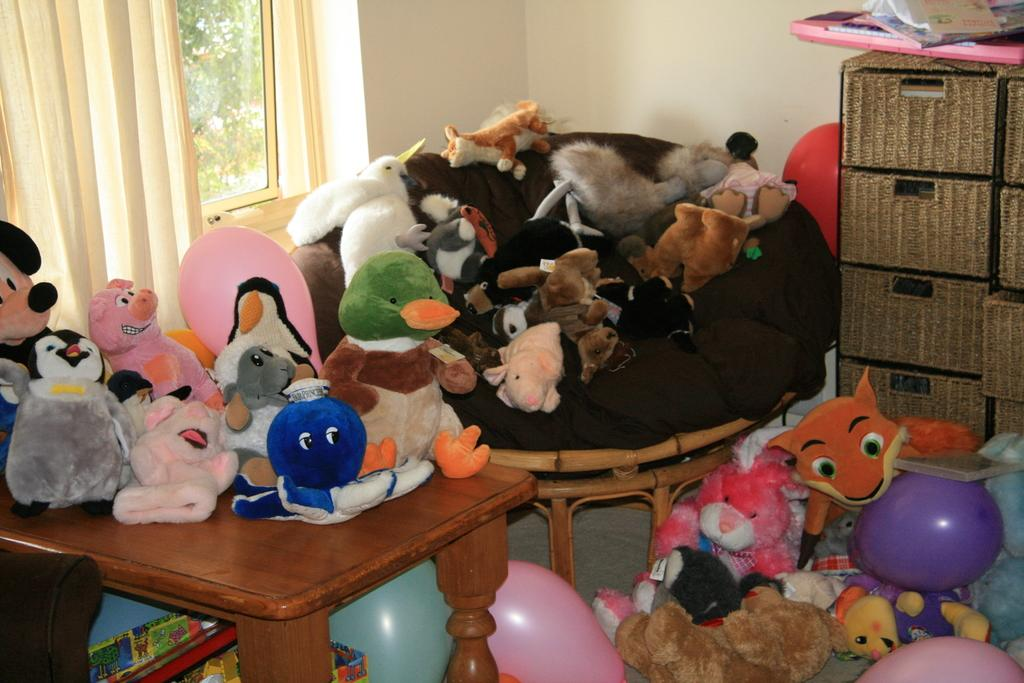What objects are present in the image? There are toys in the image. Where are the toys located? The toys are placed on a table and a sofa. Can you describe any other features in the image? There is a window in the image. What type of square experience can be seen in the image? There is no square or experience present in the image; it features toys on a table and a sofa, as well as a window. 